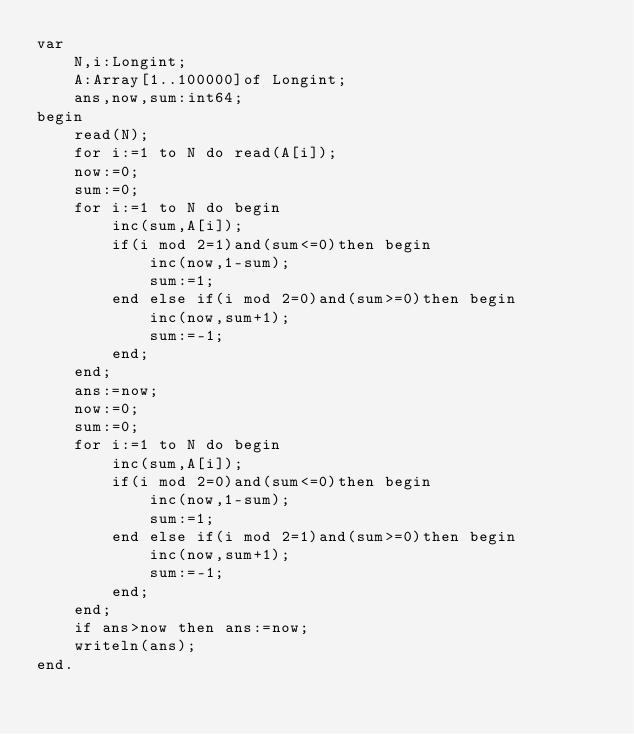Convert code to text. <code><loc_0><loc_0><loc_500><loc_500><_Pascal_>var
	N,i:Longint;
	A:Array[1..100000]of Longint;
	ans,now,sum:int64;
begin
	read(N);
	for i:=1 to N do read(A[i]);
	now:=0;
	sum:=0;
	for i:=1 to N do begin
		inc(sum,A[i]);
		if(i mod 2=1)and(sum<=0)then begin
			inc(now,1-sum);
			sum:=1;
		end else if(i mod 2=0)and(sum>=0)then begin
			inc(now,sum+1);
			sum:=-1;
		end;
	end;
	ans:=now;
	now:=0;
	sum:=0;
	for i:=1 to N do begin
		inc(sum,A[i]);
		if(i mod 2=0)and(sum<=0)then begin
			inc(now,1-sum);
			sum:=1;
		end else if(i mod 2=1)and(sum>=0)then begin
			inc(now,sum+1);
			sum:=-1;
		end;
	end;
	if ans>now then ans:=now;
	writeln(ans);
end.
</code> 